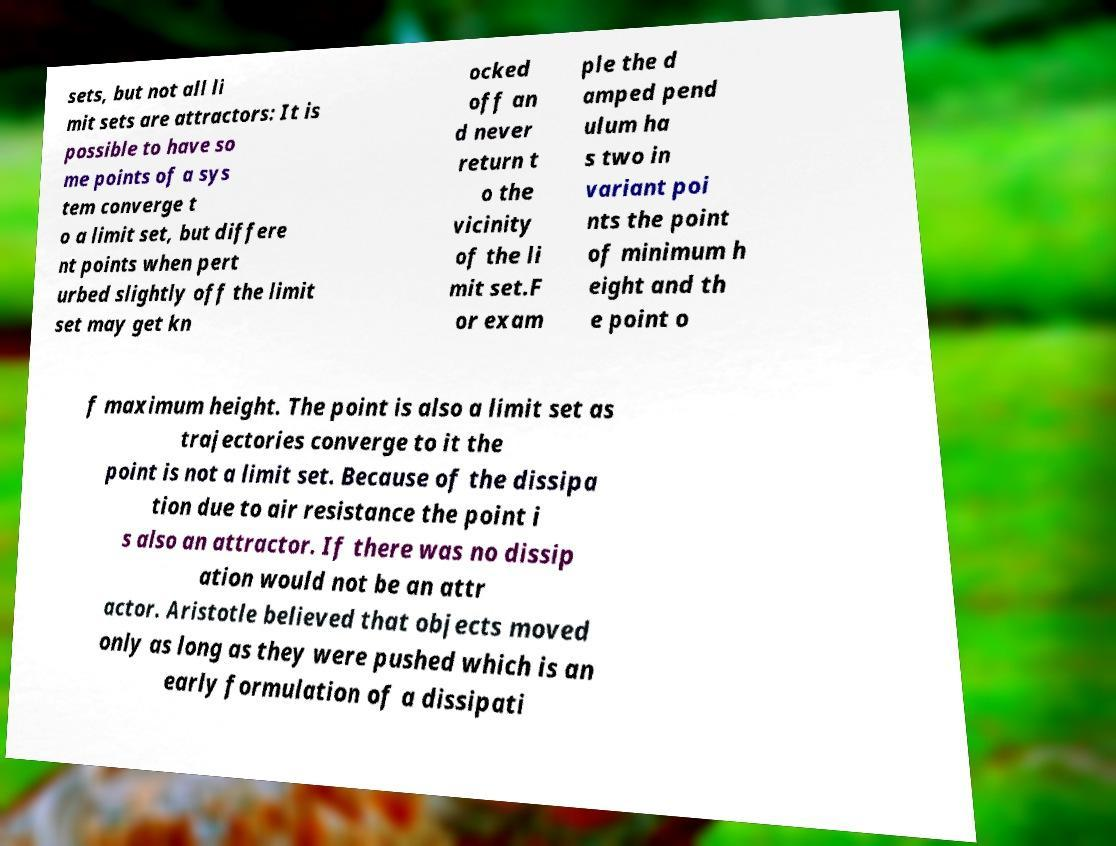There's text embedded in this image that I need extracted. Can you transcribe it verbatim? sets, but not all li mit sets are attractors: It is possible to have so me points of a sys tem converge t o a limit set, but differe nt points when pert urbed slightly off the limit set may get kn ocked off an d never return t o the vicinity of the li mit set.F or exam ple the d amped pend ulum ha s two in variant poi nts the point of minimum h eight and th e point o f maximum height. The point is also a limit set as trajectories converge to it the point is not a limit set. Because of the dissipa tion due to air resistance the point i s also an attractor. If there was no dissip ation would not be an attr actor. Aristotle believed that objects moved only as long as they were pushed which is an early formulation of a dissipati 